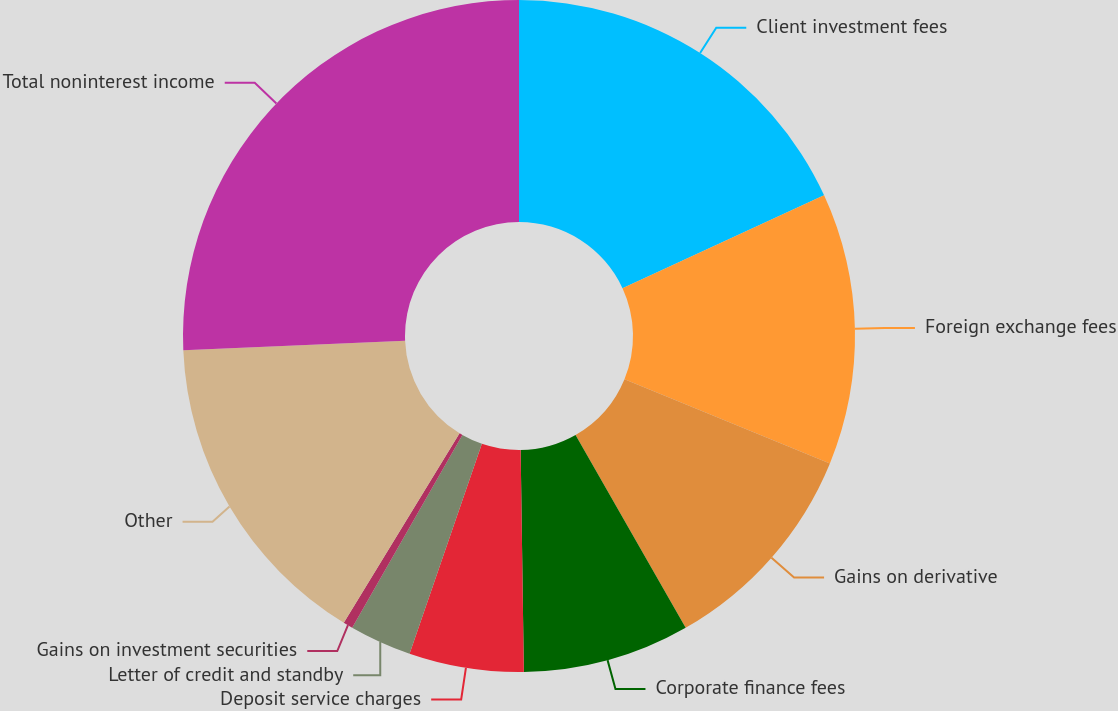Convert chart to OTSL. <chart><loc_0><loc_0><loc_500><loc_500><pie_chart><fcel>Client investment fees<fcel>Foreign exchange fees<fcel>Gains on derivative<fcel>Corporate finance fees<fcel>Deposit service charges<fcel>Letter of credit and standby<fcel>Gains on investment securities<fcel>Other<fcel>Total noninterest income<nl><fcel>18.12%<fcel>13.07%<fcel>10.55%<fcel>8.03%<fcel>5.51%<fcel>2.99%<fcel>0.46%<fcel>15.59%<fcel>25.68%<nl></chart> 